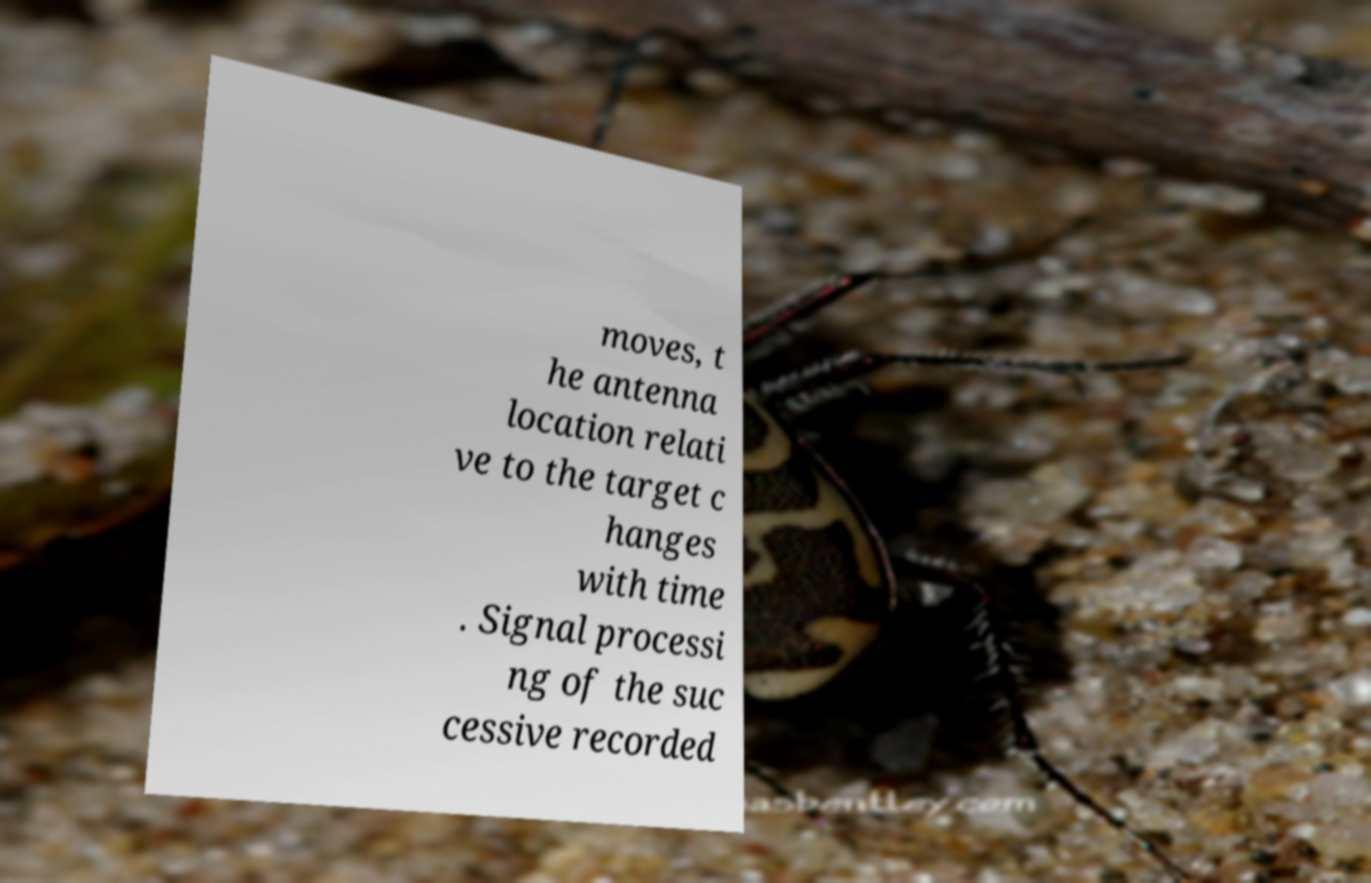Please identify and transcribe the text found in this image. moves, t he antenna location relati ve to the target c hanges with time . Signal processi ng of the suc cessive recorded 